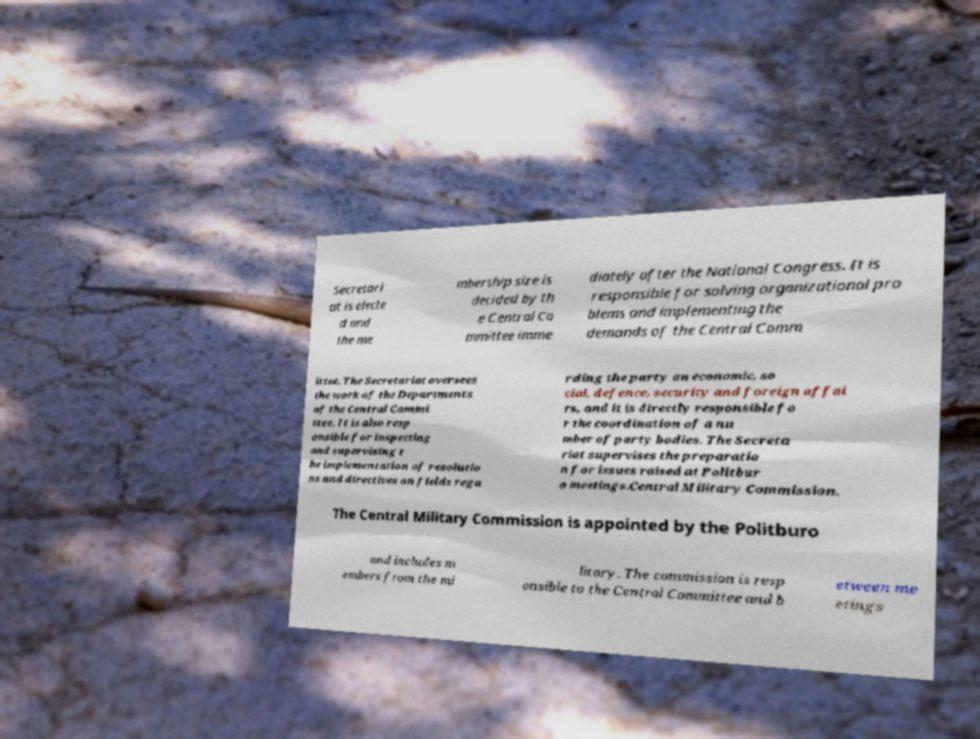Please read and relay the text visible in this image. What does it say? Secretari at is electe d and the me mbership size is decided by th e Central Co mmittee imme diately after the National Congress. It is responsible for solving organizational pro blems and implementing the demands of the Central Comm ittee. The Secretariat oversees the work of the Departments of the Central Commi ttee. It is also resp onsible for inspecting and supervising t he implementation of resolutio ns and directives on fields rega rding the party on economic, so cial, defence, security and foreign affai rs, and it is directly responsible fo r the coordination of a nu mber of party bodies. The Secreta riat supervises the preparatio n for issues raised at Politbur o meetings.Central Military Commission. The Central Military Commission is appointed by the Politburo and includes m embers from the mi litary. The commission is resp onsible to the Central Committee and b etween me etings 